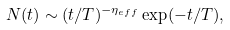Convert formula to latex. <formula><loc_0><loc_0><loc_500><loc_500>N ( t ) \sim ( t / T ) ^ { - \eta _ { e f f } } \exp ( - t / T ) ,</formula> 